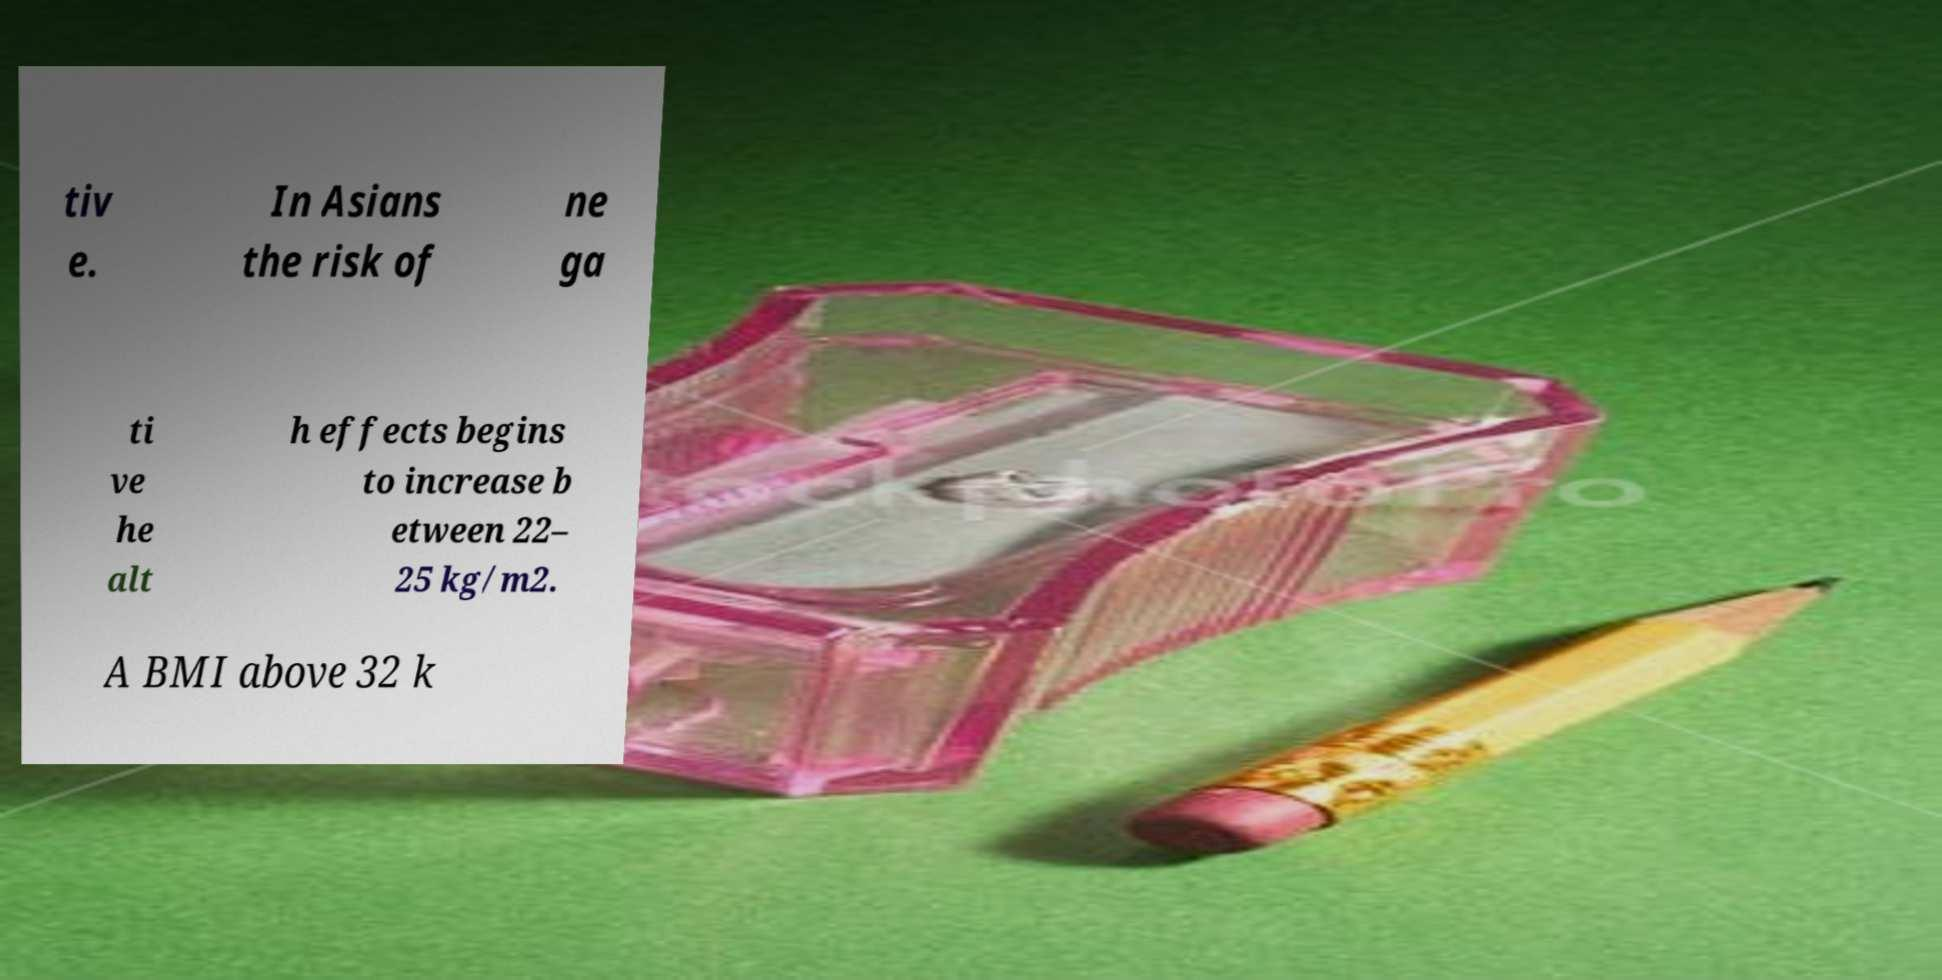Can you accurately transcribe the text from the provided image for me? tiv e. In Asians the risk of ne ga ti ve he alt h effects begins to increase b etween 22– 25 kg/m2. A BMI above 32 k 